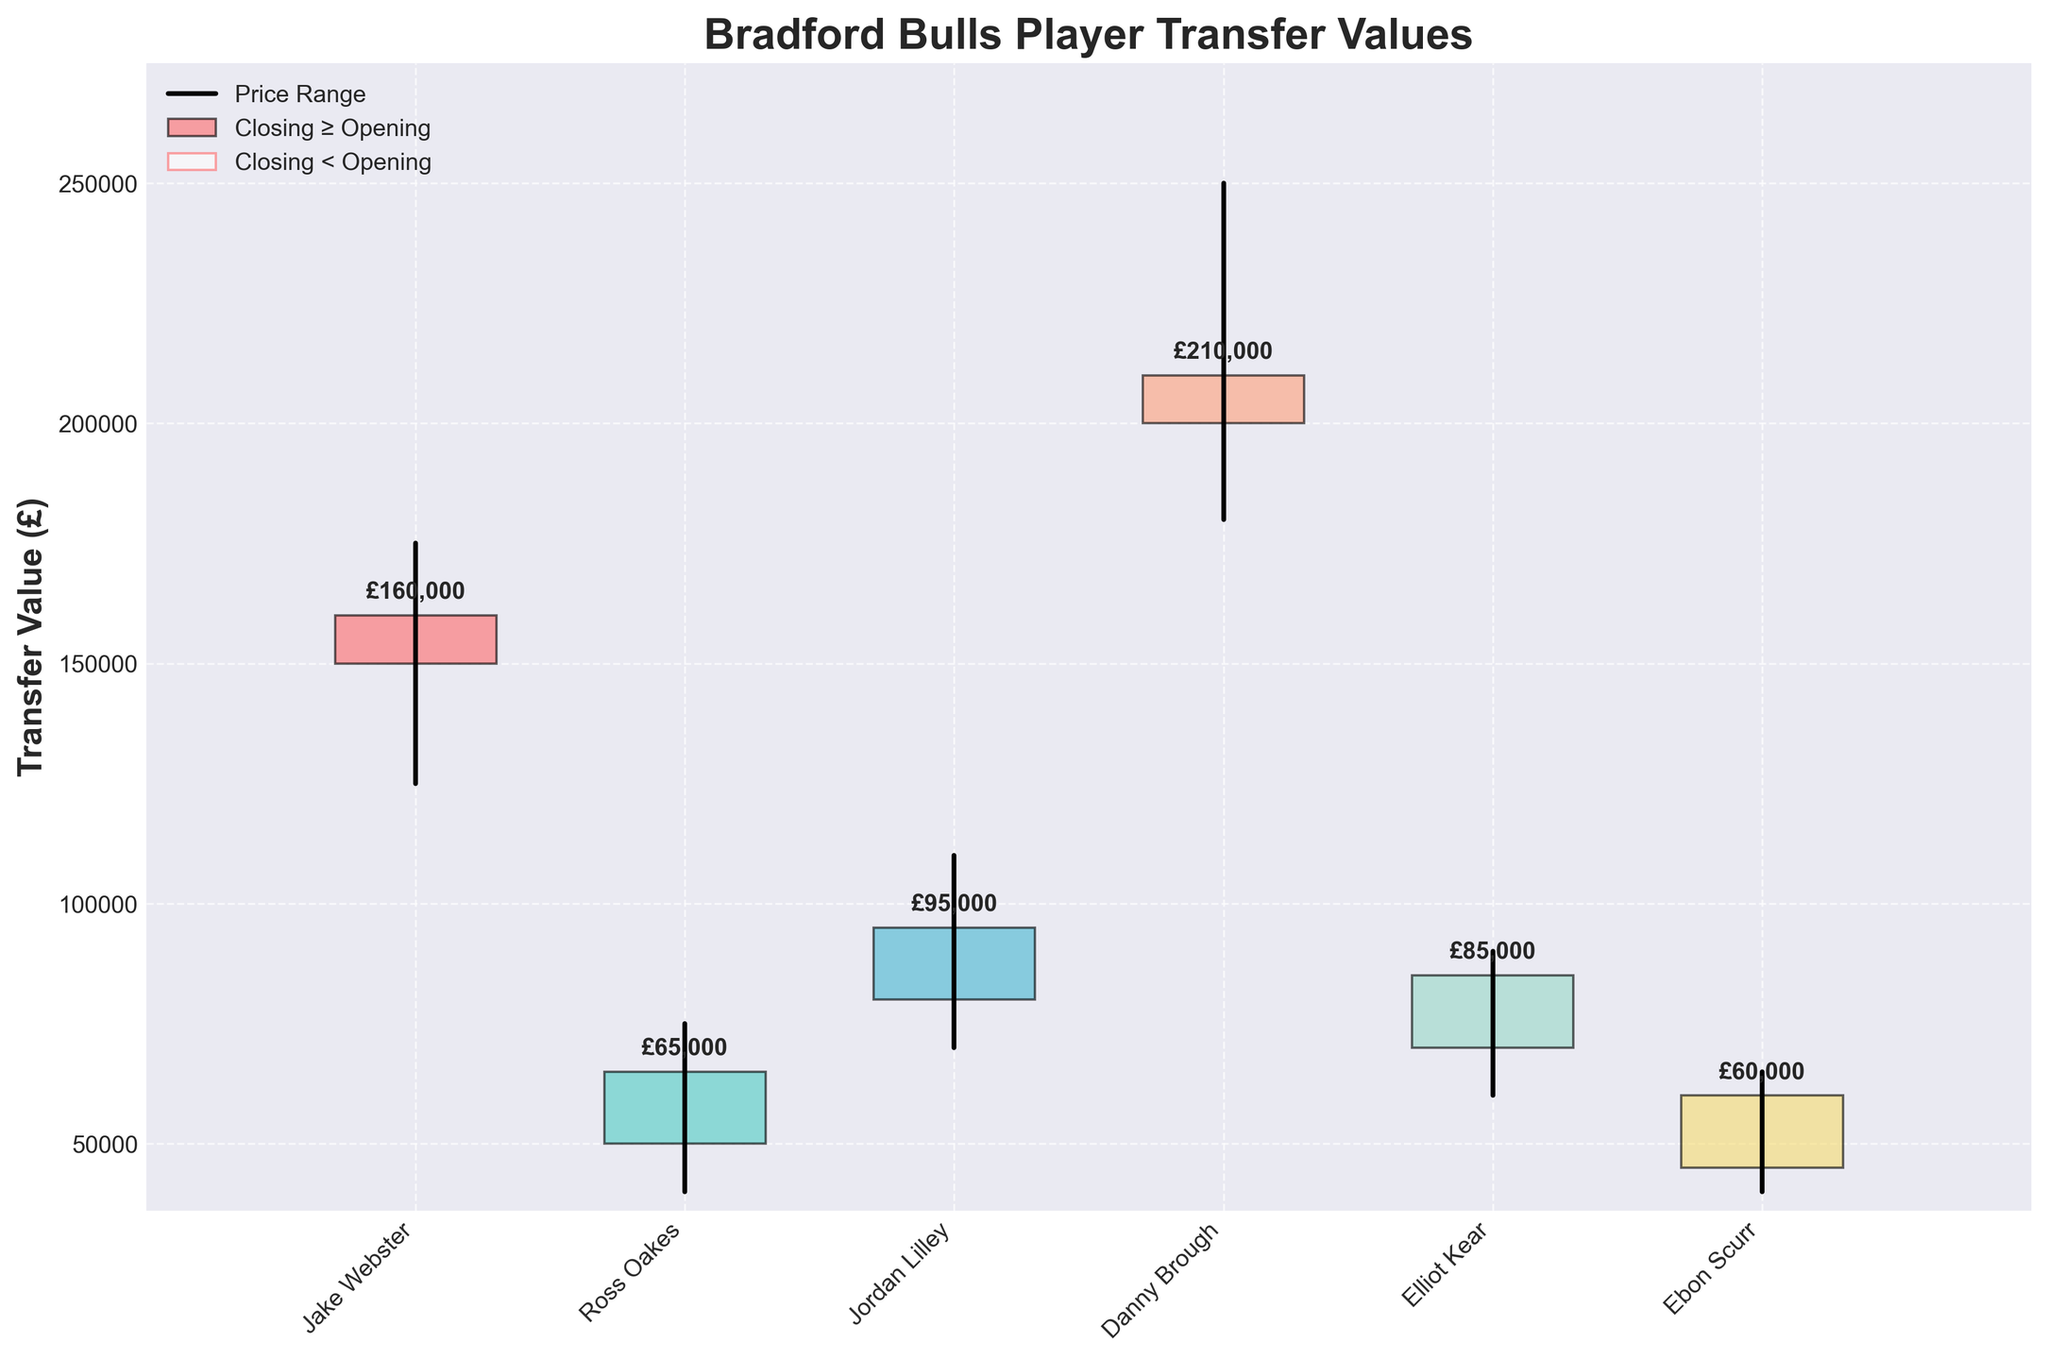What is the title of the figure? The title is usually found at the top of the figure. In this case, it reads "Bradford Bulls Player Transfer Values".
Answer: Bradford Bulls Player Transfer Values How many players are displayed in the figure? The number of players displayed corresponds to the number of data points on the x-axis. Each bar and price range line represents a player. By counting them, we find there are 6 players.
Answer: 6 What is the transfer value range (highest and lowest) for Danny Brough in the 2021-2022 season? For Danny Brough, the transfer value ranges from the lowest point to the highest point between the opening and closing prices. The lowest value is £180,000 and the highest value is £250,000.
Answer: £180,000 to £250,000 Which player had the highest closing value? To find the player with the highest closing value, look for the highest closing price indicated by the top of a bar that ends at or above the opening price. Danny Brough's closing value of £210,000 is the highest.
Answer: Danny Brough Compare Jake Webster and Ebon Scurr. Whose transfer value had a larger range within a single season? Calculate the range for each player by subtracting the lowest value from the highest value for that season. Jake Webster: £175,000 - £125,000 = £50,000. Ebon Scurr: £650,000 - £400,000 = £250,000. Jake Webster had a larger range.
Answer: Jake Webster Which player had the smallest difference between their opening and closing values? Calculate the difference between the opening and closing values for each player. The smallest difference is for the player where this value is minimal. Ross Oakes' difference is £15,000 (65,000 - 50,000).
Answer: Ross Oakes What is the average opening value for all players? Add up all the opening values of the players and then divide by the number of players. (£150,000 + £50,000 + £80,000 + £200,000 + £70,000 + £45,000) / 6 = £99,167.
Answer: £99,167 Which season had the highest lowest value? Identify each player's lowest value point and compare them across the seasons. Danny Brough in the 2021-2022 season had the highest lowest value at £180,000.
Answer: 2021-2022 season What is the total range of values for the entire dataset? The total range is the difference between the highest and the lowest values in the entire figure. The highest value is £250,000 (Danny Brough); the lowest is £40,000 (Ross Oakes and Ebon Scurr). So, the range is £250,000 - £40,000 = £210,000.
Answer: £210,000 